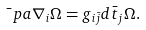Convert formula to latex. <formula><loc_0><loc_0><loc_500><loc_500>\bar { \ } p a \nabla _ { i } \Omega = g _ { i \bar { j } } d \bar { t } _ { j } \Omega .</formula> 